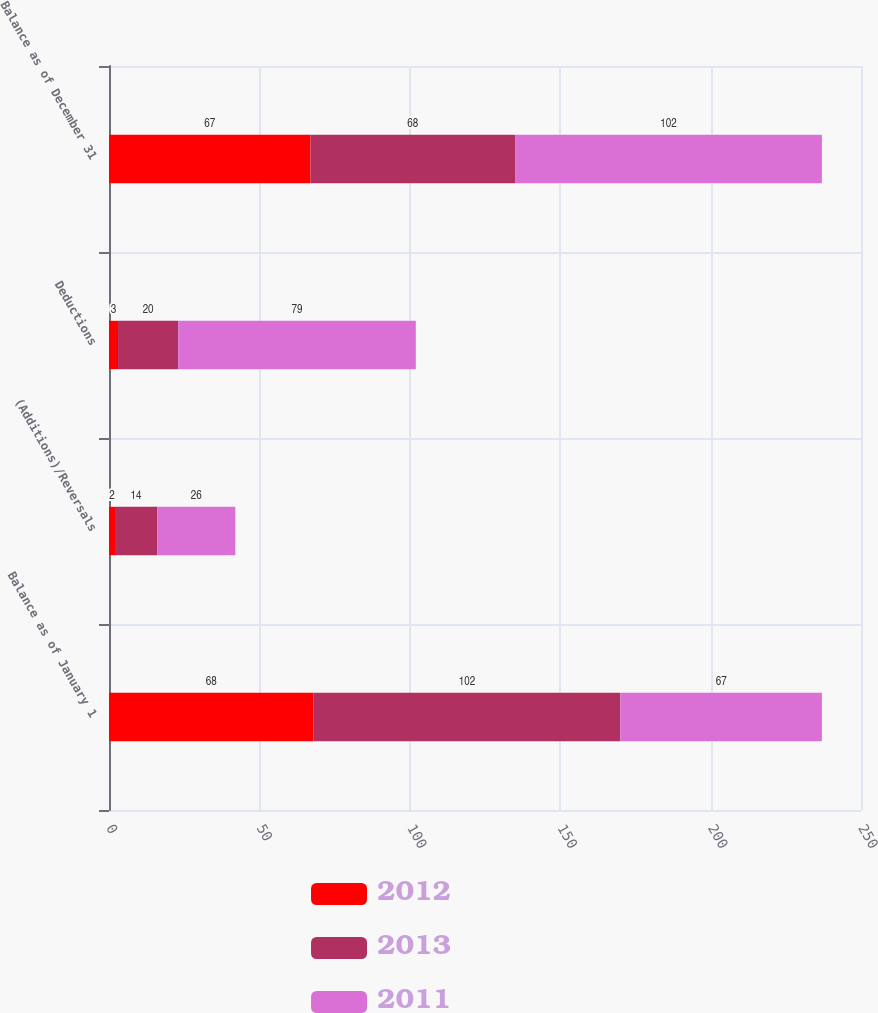Convert chart. <chart><loc_0><loc_0><loc_500><loc_500><stacked_bar_chart><ecel><fcel>Balance as of January 1<fcel>(Additions)/Reversals<fcel>Deductions<fcel>Balance as of December 31<nl><fcel>2012<fcel>68<fcel>2<fcel>3<fcel>67<nl><fcel>2013<fcel>102<fcel>14<fcel>20<fcel>68<nl><fcel>2011<fcel>67<fcel>26<fcel>79<fcel>102<nl></chart> 